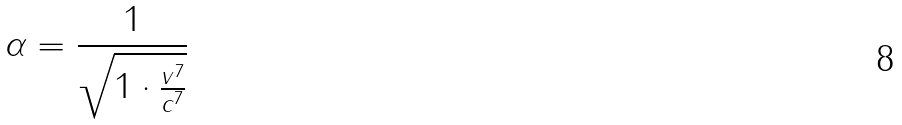Convert formula to latex. <formula><loc_0><loc_0><loc_500><loc_500>\alpha = \frac { 1 } { \sqrt { 1 \cdot \frac { v ^ { 7 } } { c ^ { 7 } } } }</formula> 